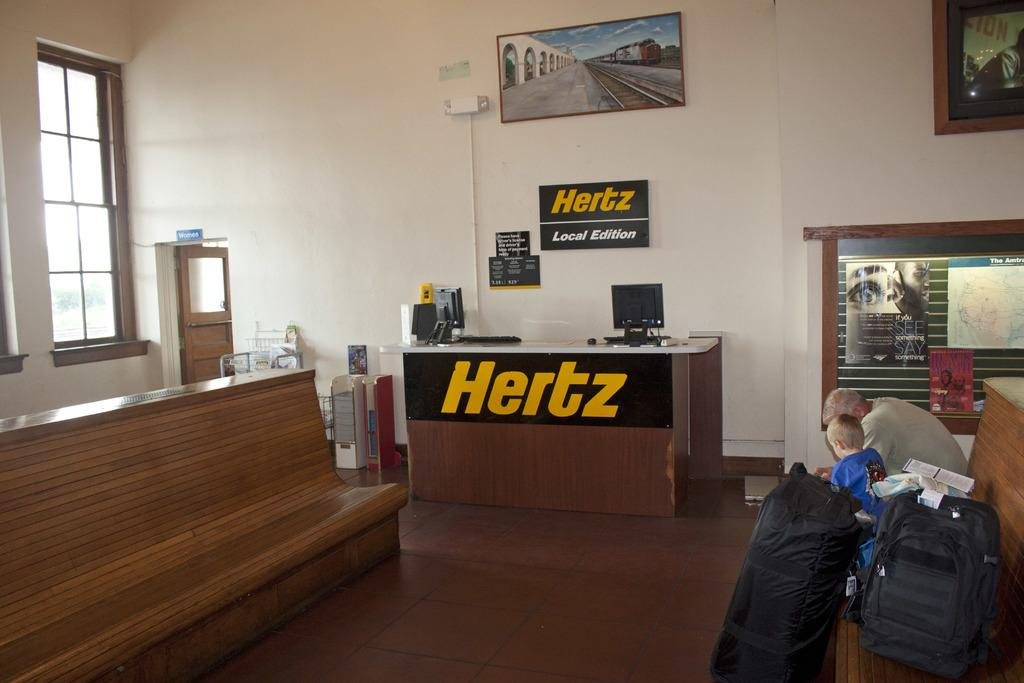What are the people in the image doing? The people in the image are sitting on a bench. What objects are the people holding or carrying? The people have luggage bags with them. What is the location of the bench in the image? The bench is in front of a table. What is the relationship between the table and the wall in the image? The table is against a wall. What electronic device is on the table? There is a computer on the table. How many books can be seen on the road in the image? There are no books or roads present in the image. 